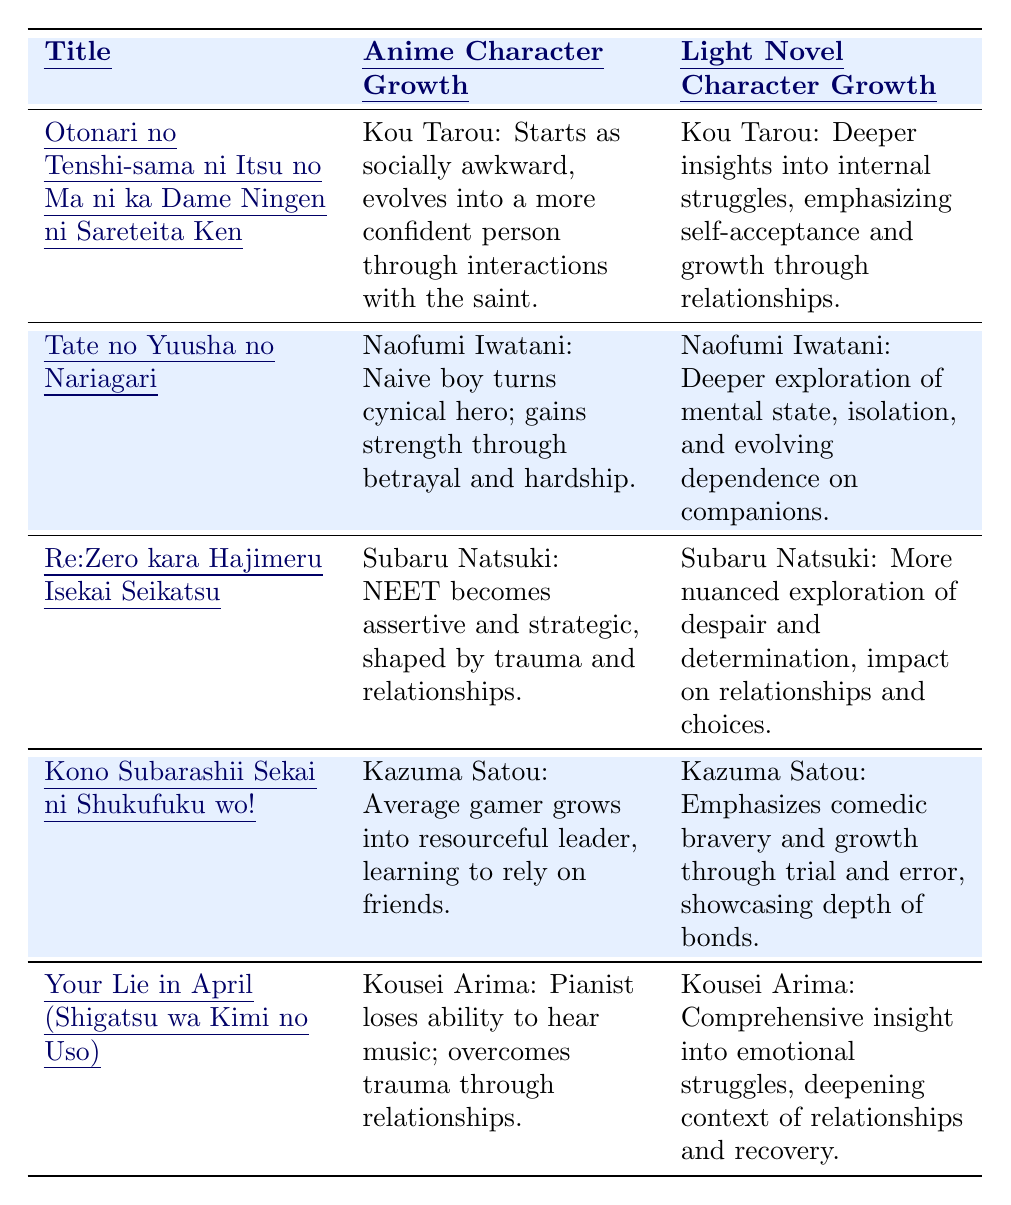What is the character name in "Otonari no Tenshi-sama ni Itsu no Ma ni ka Dame Ningen ni Sareteita Ken"? The table specifically lists the character in the anime and light novel as Kou Tarou.
Answer: Kou Tarou Which character undergoes significant change in "Tate no Yuusha no Nariagari"? The table indicates that Naofumi Iwatani is the character who undergoes significant change from naive boy to cynical hero.
Answer: Naofumi Iwatani Does Subaru Natsuki's character growth differ between the anime and light novel? Yes, the table describes Subaru's journeys in both formats but highlights that the light novel has a more nuanced exploration of his character.
Answer: Yes Which character's growth involves overcoming trauma through relationships? The table indicates that Kousei Arima's growth involves overcoming trauma related to losing his ability to hear music, facilitated by his relationships.
Answer: Kousei Arima How does Naofumi Iwatani's growth in the light novel compare to his growth in the anime? According to the table, while both versions show a transformation, the light novel provides a deeper exploration of Naofumi's isolation and dependence on companions, whereas the anime simplifies this to gaining strength through hardship.
Answer: The light novel offers deeper insights In which title is the main character described as starting as a NEET? The table notes that Subaru Natsuki from "Re:Zero kara Hajimeru Isekai Seikatsu" is characterized as starting as a typical NEET.
Answer: Re:Zero kara Hajimeru Isekai Seikatsu What common theme can be found in the character growth across all titles listed in the table? The table emphasizes that character growth in all titles is closely linked to relationships and personal struggles, showcasing a common theme of overcoming obstacles with support.
Answer: Overcoming personal struggles through relationships Which character exhibits both comedic bravery and resourcefulness in the light novel? The table mentions that Kazuma Satou showcases comedic bravery and resourcefulness, particularly noted in the light novel format.
Answer: Kazuma Satou How does Kousei Arima’s experience differ between the anime and light novel in terms of emotional struggles? The table highlights that while both formats address Kousei's emotional struggles, the light novel provides a more comprehensive insight into those struggles and their impact on his recovery.
Answer: The light novel has more comprehensive insights Which character demonstrates growth through betrayal and hardship according to the table? The table indicates that Naofumi Iwatani demonstrates this type of growth, turning from a naive character into a resilient hero because of betrayal and hardship.
Answer: Naofumi Iwatani What is the general trend observed in character arcs within the table? It is evident from the table that characters start with various personal issues or flaws, and evolve significantly through the influence of their relationships, emphasizing growth over time.
Answer: Characters grow through relationships 